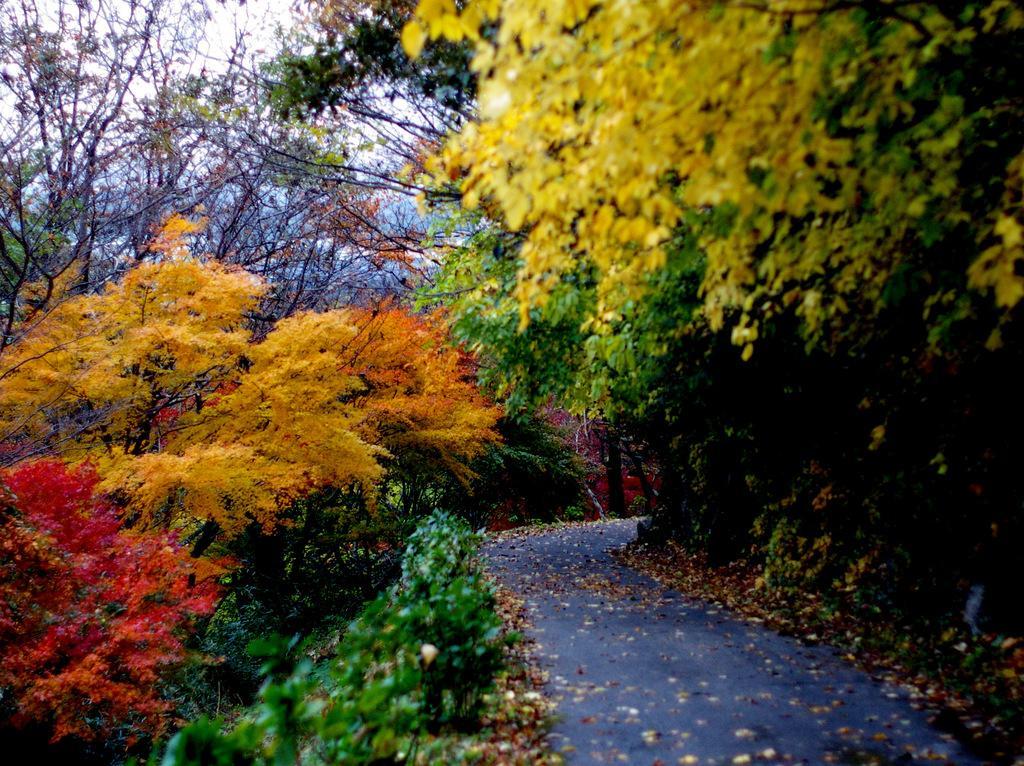In one or two sentences, can you explain what this image depicts? In the foreground of this image, there is a road and on either side there are trees with color leaves. In the background, there is the sky. 